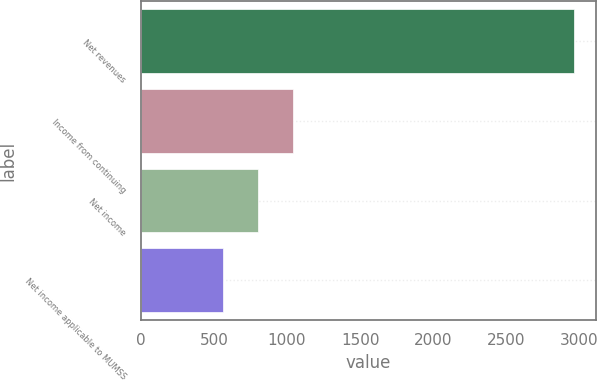Convert chart. <chart><loc_0><loc_0><loc_500><loc_500><bar_chart><fcel>Net revenues<fcel>Income from continuing<fcel>Net income<fcel>Net income applicable to MUMSS<nl><fcel>2961<fcel>1044.2<fcel>804.6<fcel>565<nl></chart> 